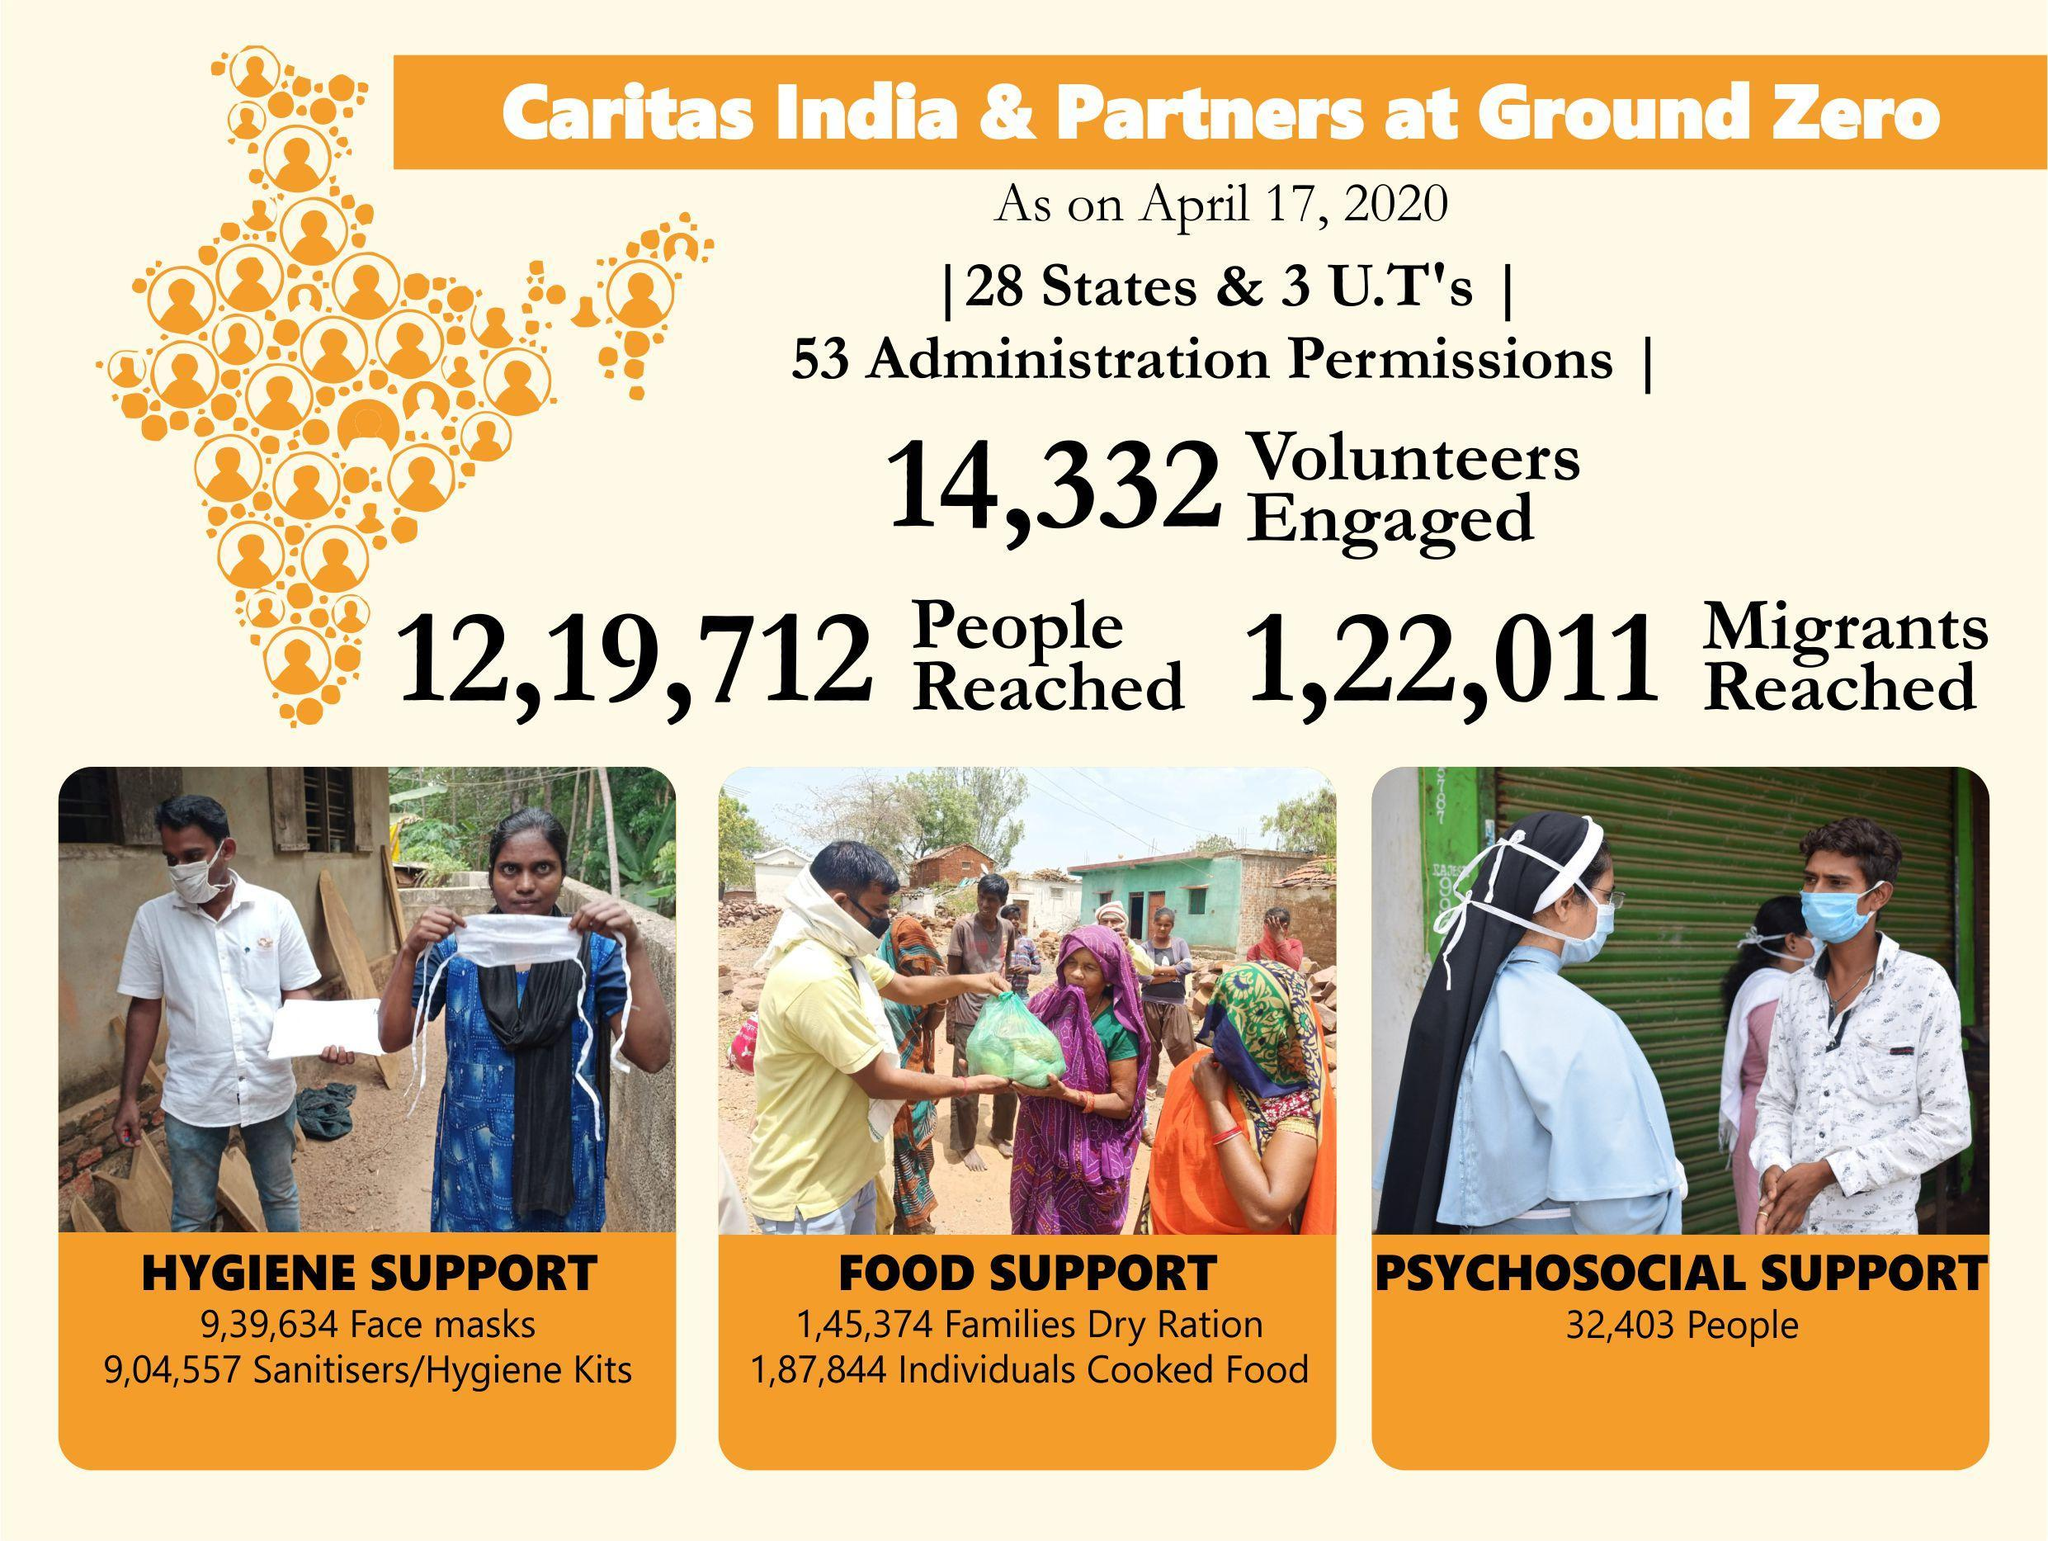How many people were given psychosocial support by the Caritas India & Partners as on April 17, 2020?
Answer the question with a short phrase. 32,403 